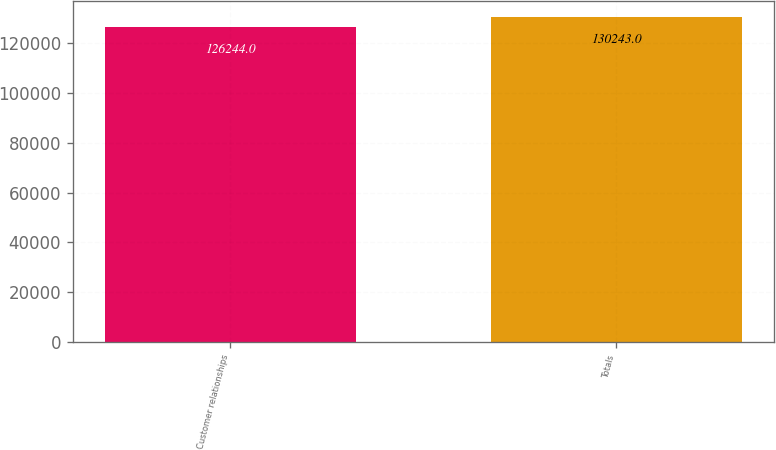Convert chart. <chart><loc_0><loc_0><loc_500><loc_500><bar_chart><fcel>Customer relationships<fcel>Totals<nl><fcel>126244<fcel>130243<nl></chart> 